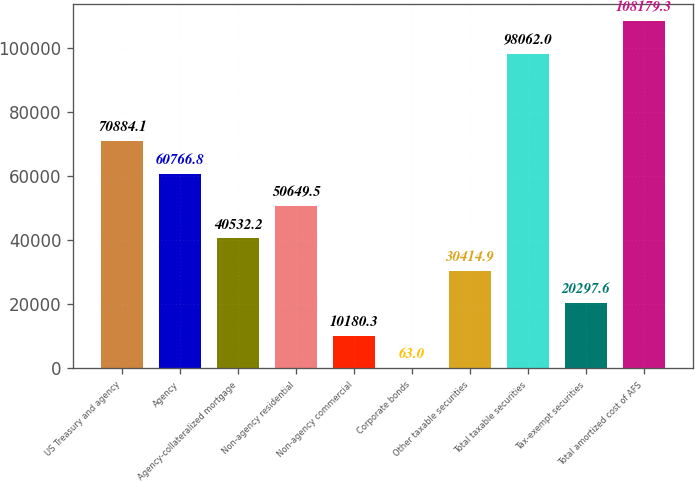<chart> <loc_0><loc_0><loc_500><loc_500><bar_chart><fcel>US Treasury and agency<fcel>Agency<fcel>Agency-collateralized mortgage<fcel>Non-agency residential<fcel>Non-agency commercial<fcel>Corporate bonds<fcel>Other taxable securities<fcel>Total taxable securities<fcel>Tax-exempt securities<fcel>Total amortized cost of AFS<nl><fcel>70884.1<fcel>60766.8<fcel>40532.2<fcel>50649.5<fcel>10180.3<fcel>63<fcel>30414.9<fcel>98062<fcel>20297.6<fcel>108179<nl></chart> 